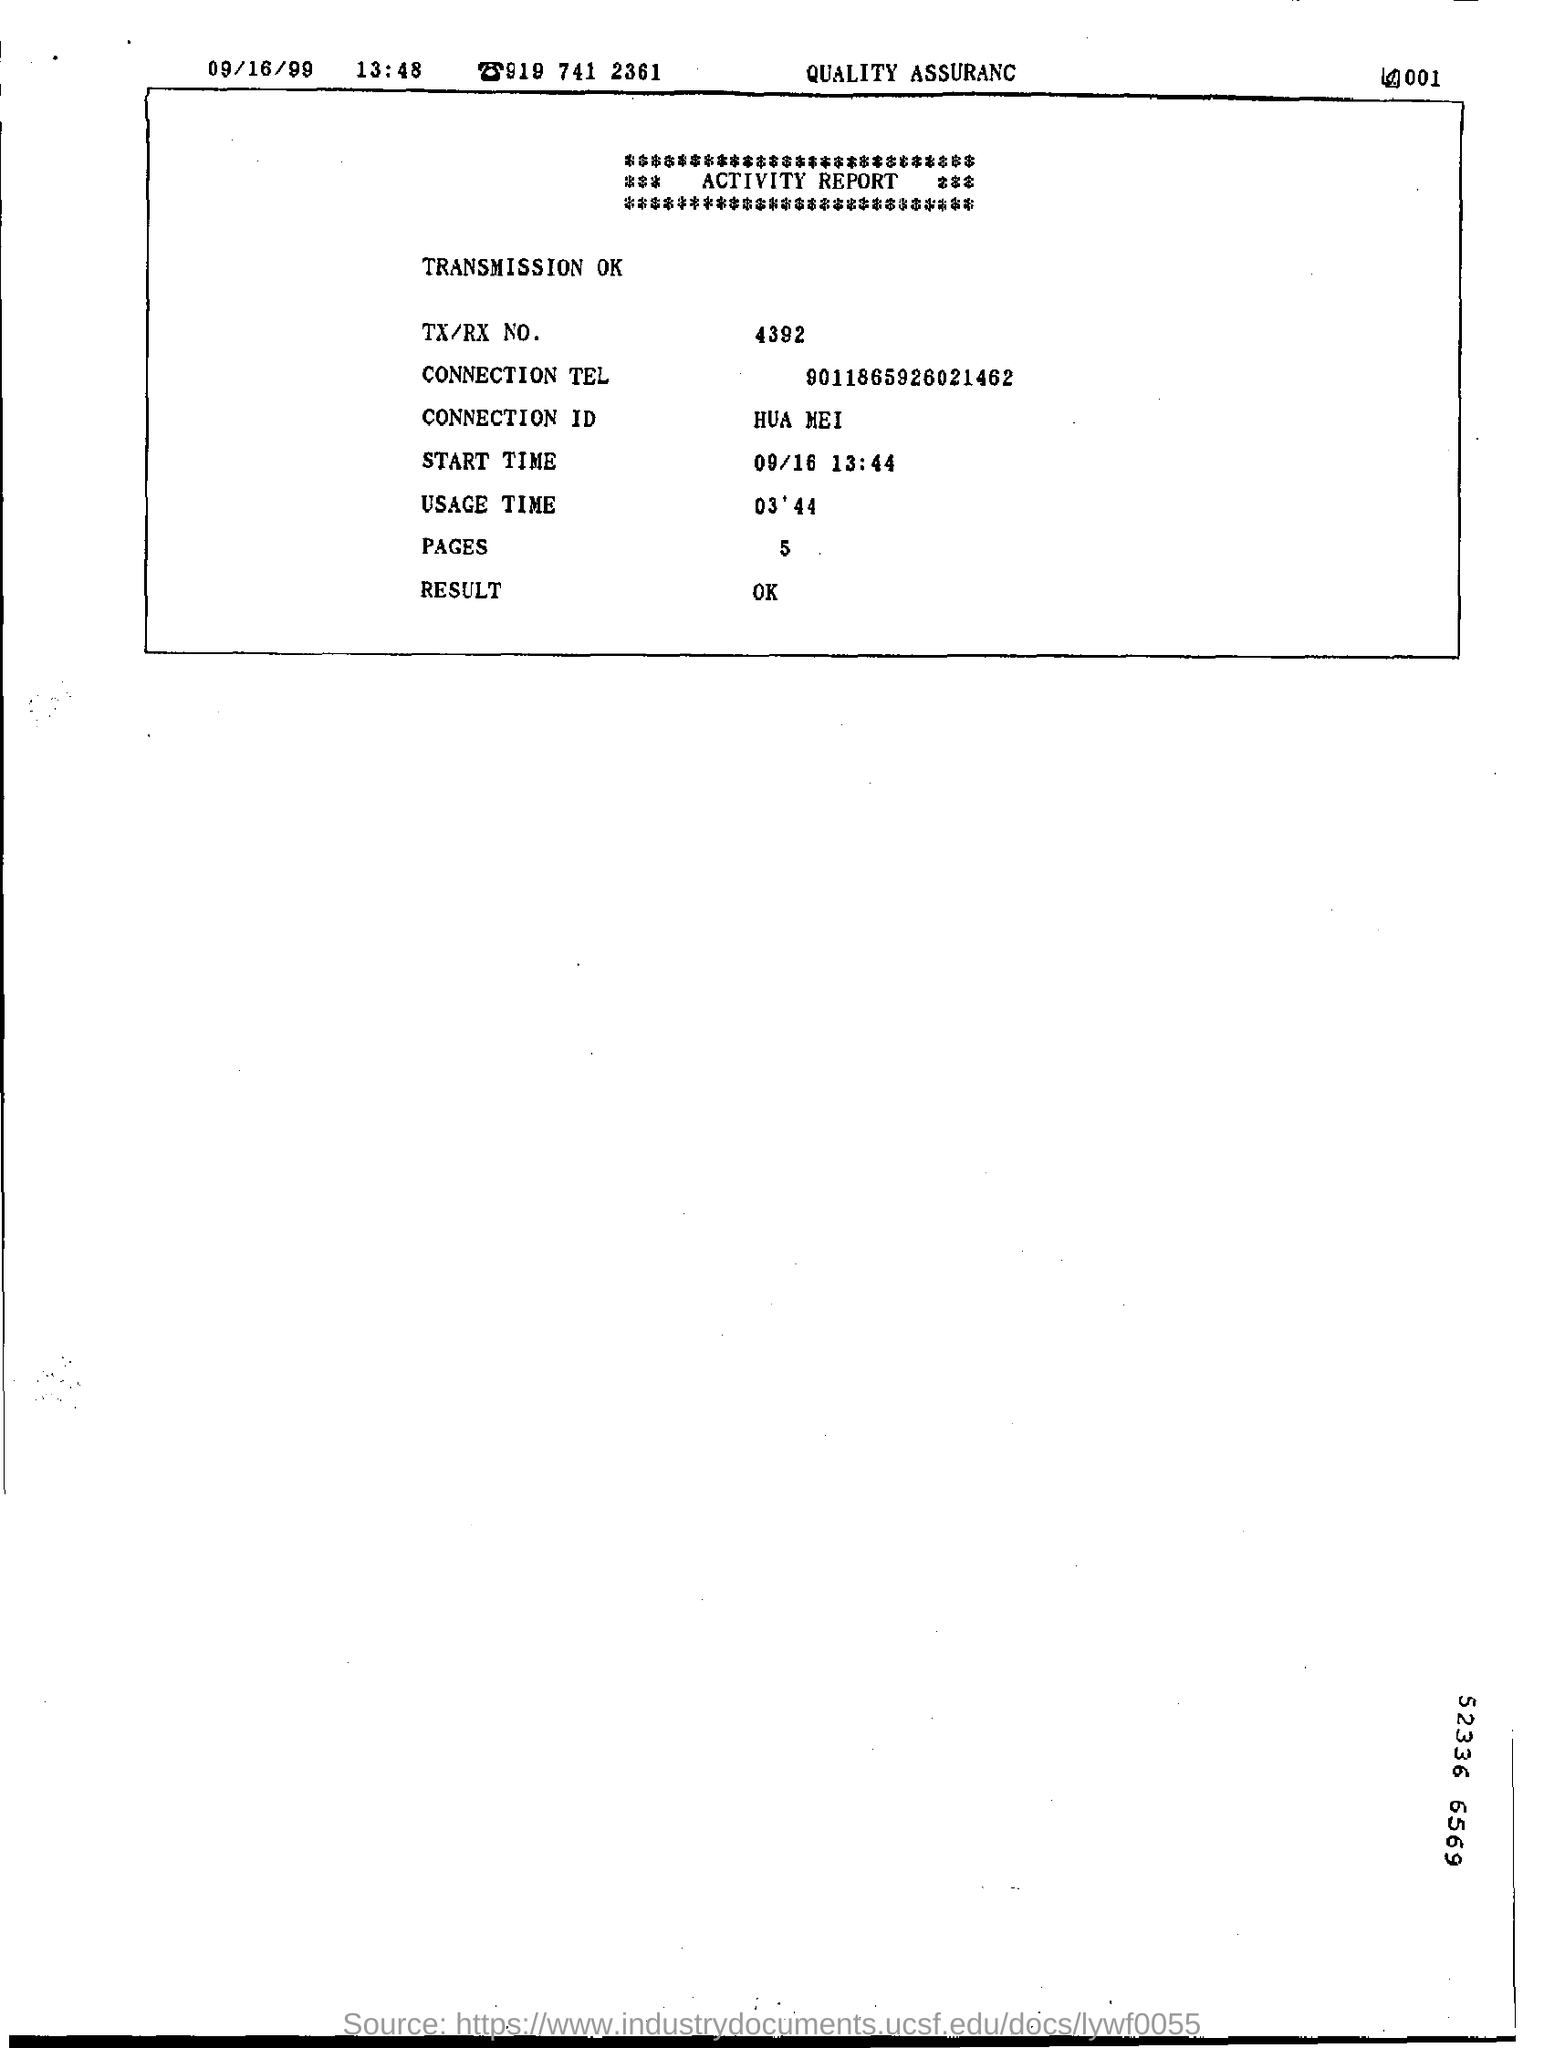No. of pages mentioned in the document?
Your answer should be compact. 5. 